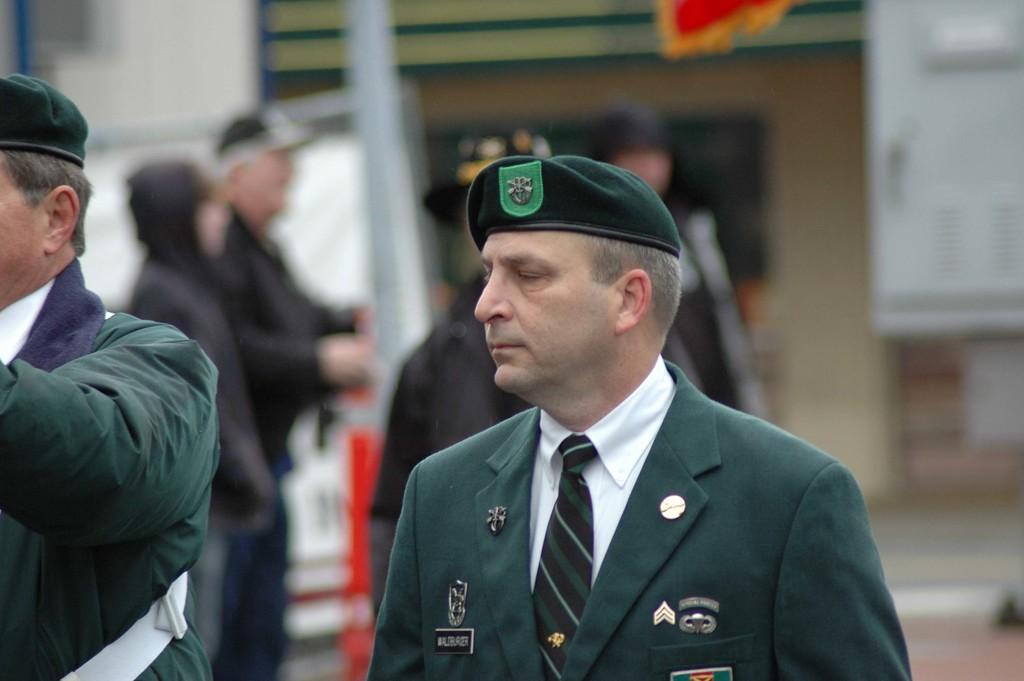What can be seen in the image? There are people standing in the image. What are the people wearing on their heads? The people are wearing caps on their heads. What type of structure is visible in the image? There is a building in the image. What is the flag associated with? The flag is associated with the building or the location. Can you tell me how many aunts are present in the image? There is no mention of an aunt in the image, so it cannot be determined from the image. What type of jellyfish can be seen swimming in the image? There is no jellyfish present in the image; it features people standing, wearing caps, and a building with a flag. 